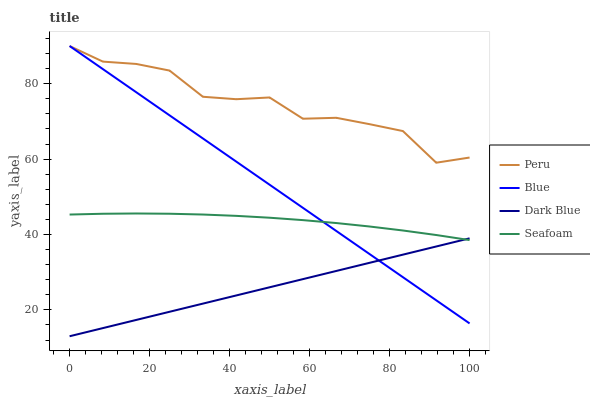Does Dark Blue have the minimum area under the curve?
Answer yes or no. Yes. Does Peru have the maximum area under the curve?
Answer yes or no. Yes. Does Seafoam have the minimum area under the curve?
Answer yes or no. No. Does Seafoam have the maximum area under the curve?
Answer yes or no. No. Is Dark Blue the smoothest?
Answer yes or no. Yes. Is Peru the roughest?
Answer yes or no. Yes. Is Seafoam the smoothest?
Answer yes or no. No. Is Seafoam the roughest?
Answer yes or no. No. Does Seafoam have the lowest value?
Answer yes or no. No. Does Seafoam have the highest value?
Answer yes or no. No. Is Dark Blue less than Peru?
Answer yes or no. Yes. Is Peru greater than Seafoam?
Answer yes or no. Yes. Does Dark Blue intersect Peru?
Answer yes or no. No. 